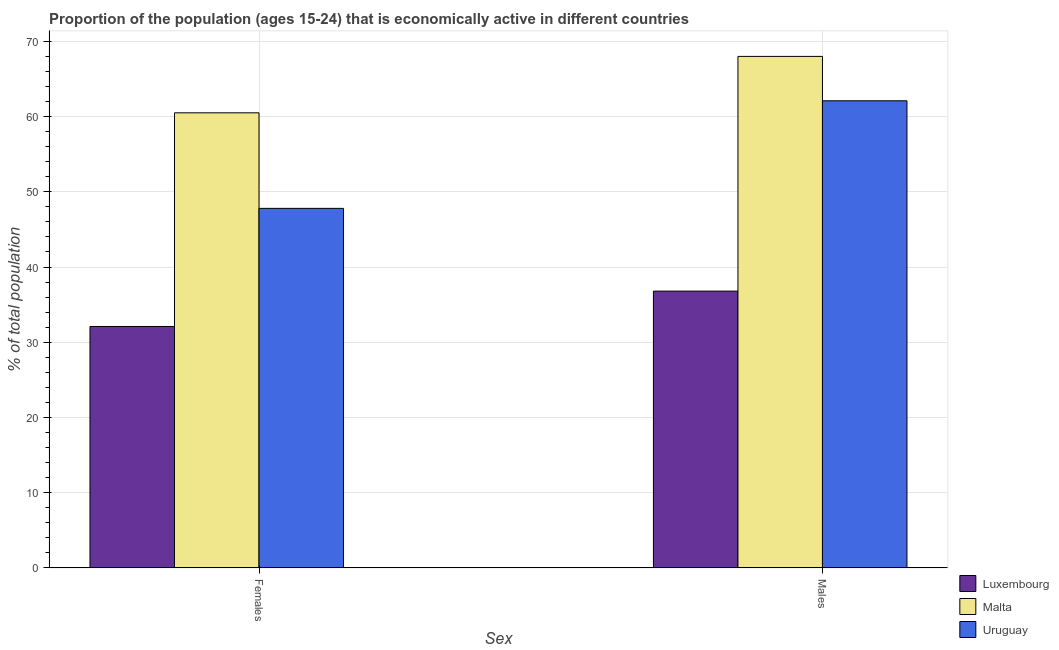How many different coloured bars are there?
Your answer should be compact. 3. Are the number of bars on each tick of the X-axis equal?
Ensure brevity in your answer.  Yes. How many bars are there on the 2nd tick from the left?
Provide a short and direct response. 3. How many bars are there on the 1st tick from the right?
Your response must be concise. 3. What is the label of the 2nd group of bars from the left?
Ensure brevity in your answer.  Males. What is the percentage of economically active female population in Malta?
Your answer should be very brief. 60.5. Across all countries, what is the minimum percentage of economically active male population?
Offer a very short reply. 36.8. In which country was the percentage of economically active female population maximum?
Keep it short and to the point. Malta. In which country was the percentage of economically active male population minimum?
Provide a succinct answer. Luxembourg. What is the total percentage of economically active male population in the graph?
Your response must be concise. 166.9. What is the difference between the percentage of economically active male population in Uruguay and that in Luxembourg?
Your response must be concise. 25.3. What is the difference between the percentage of economically active male population in Luxembourg and the percentage of economically active female population in Malta?
Offer a very short reply. -23.7. What is the average percentage of economically active male population per country?
Keep it short and to the point. 55.63. What is the difference between the percentage of economically active male population and percentage of economically active female population in Luxembourg?
Your response must be concise. 4.7. What is the ratio of the percentage of economically active female population in Uruguay to that in Luxembourg?
Ensure brevity in your answer.  1.49. What does the 1st bar from the left in Males represents?
Your answer should be compact. Luxembourg. What does the 3rd bar from the right in Males represents?
Provide a short and direct response. Luxembourg. How many bars are there?
Offer a very short reply. 6. Are all the bars in the graph horizontal?
Provide a succinct answer. No. How many countries are there in the graph?
Give a very brief answer. 3. What is the difference between two consecutive major ticks on the Y-axis?
Your response must be concise. 10. Where does the legend appear in the graph?
Your answer should be compact. Bottom right. How many legend labels are there?
Give a very brief answer. 3. What is the title of the graph?
Your answer should be very brief. Proportion of the population (ages 15-24) that is economically active in different countries. What is the label or title of the X-axis?
Keep it short and to the point. Sex. What is the label or title of the Y-axis?
Give a very brief answer. % of total population. What is the % of total population in Luxembourg in Females?
Offer a very short reply. 32.1. What is the % of total population of Malta in Females?
Offer a very short reply. 60.5. What is the % of total population of Uruguay in Females?
Your response must be concise. 47.8. What is the % of total population of Luxembourg in Males?
Your answer should be very brief. 36.8. What is the % of total population of Uruguay in Males?
Your answer should be compact. 62.1. Across all Sex, what is the maximum % of total population of Luxembourg?
Keep it short and to the point. 36.8. Across all Sex, what is the maximum % of total population of Uruguay?
Make the answer very short. 62.1. Across all Sex, what is the minimum % of total population in Luxembourg?
Make the answer very short. 32.1. Across all Sex, what is the minimum % of total population in Malta?
Provide a short and direct response. 60.5. Across all Sex, what is the minimum % of total population in Uruguay?
Provide a short and direct response. 47.8. What is the total % of total population in Luxembourg in the graph?
Ensure brevity in your answer.  68.9. What is the total % of total population in Malta in the graph?
Give a very brief answer. 128.5. What is the total % of total population of Uruguay in the graph?
Keep it short and to the point. 109.9. What is the difference between the % of total population of Luxembourg in Females and that in Males?
Offer a very short reply. -4.7. What is the difference between the % of total population in Uruguay in Females and that in Males?
Keep it short and to the point. -14.3. What is the difference between the % of total population in Luxembourg in Females and the % of total population in Malta in Males?
Your answer should be compact. -35.9. What is the difference between the % of total population in Luxembourg in Females and the % of total population in Uruguay in Males?
Your answer should be very brief. -30. What is the difference between the % of total population of Malta in Females and the % of total population of Uruguay in Males?
Give a very brief answer. -1.6. What is the average % of total population of Luxembourg per Sex?
Make the answer very short. 34.45. What is the average % of total population in Malta per Sex?
Your response must be concise. 64.25. What is the average % of total population of Uruguay per Sex?
Your answer should be very brief. 54.95. What is the difference between the % of total population in Luxembourg and % of total population in Malta in Females?
Make the answer very short. -28.4. What is the difference between the % of total population of Luxembourg and % of total population of Uruguay in Females?
Provide a short and direct response. -15.7. What is the difference between the % of total population of Luxembourg and % of total population of Malta in Males?
Keep it short and to the point. -31.2. What is the difference between the % of total population of Luxembourg and % of total population of Uruguay in Males?
Make the answer very short. -25.3. What is the difference between the % of total population in Malta and % of total population in Uruguay in Males?
Offer a very short reply. 5.9. What is the ratio of the % of total population in Luxembourg in Females to that in Males?
Make the answer very short. 0.87. What is the ratio of the % of total population in Malta in Females to that in Males?
Provide a succinct answer. 0.89. What is the ratio of the % of total population of Uruguay in Females to that in Males?
Offer a very short reply. 0.77. What is the difference between the highest and the second highest % of total population in Luxembourg?
Your response must be concise. 4.7. What is the difference between the highest and the second highest % of total population of Malta?
Ensure brevity in your answer.  7.5. What is the difference between the highest and the second highest % of total population of Uruguay?
Provide a succinct answer. 14.3. What is the difference between the highest and the lowest % of total population of Uruguay?
Provide a short and direct response. 14.3. 